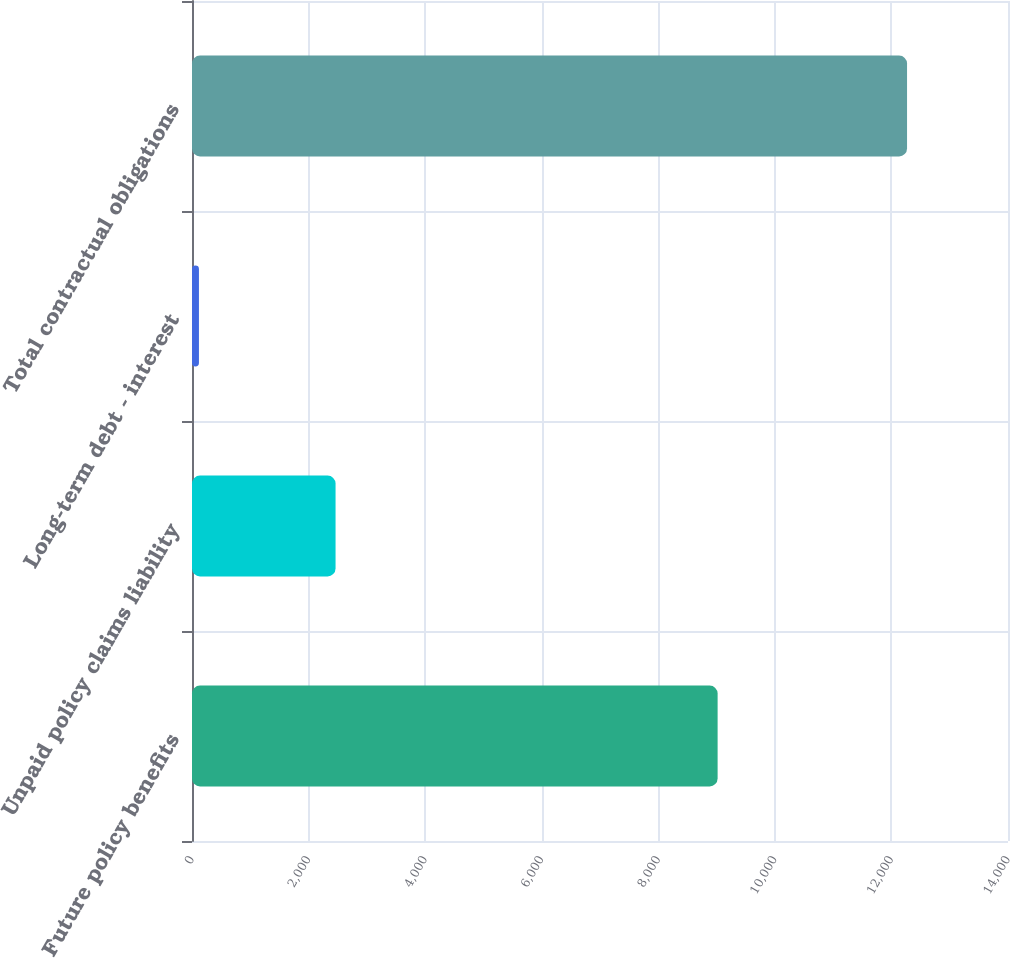Convert chart. <chart><loc_0><loc_0><loc_500><loc_500><bar_chart><fcel>Future policy benefits<fcel>Unpaid policy claims liability<fcel>Long-term debt - interest<fcel>Total contractual obligations<nl><fcel>9018<fcel>2463<fcel>119<fcel>12268<nl></chart> 